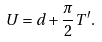<formula> <loc_0><loc_0><loc_500><loc_500>U = d + \frac { \pi } { 2 } T ^ { \prime } .</formula> 